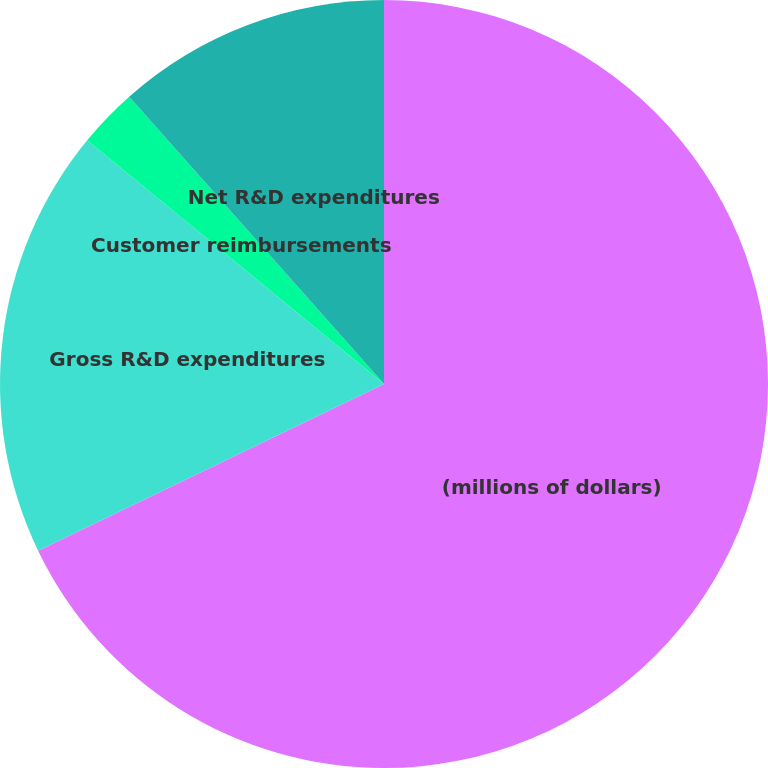<chart> <loc_0><loc_0><loc_500><loc_500><pie_chart><fcel>(millions of dollars)<fcel>Gross R&D expenditures<fcel>Customer reimbursements<fcel>Net R&D expenditures<nl><fcel>67.85%<fcel>18.09%<fcel>2.51%<fcel>11.55%<nl></chart> 